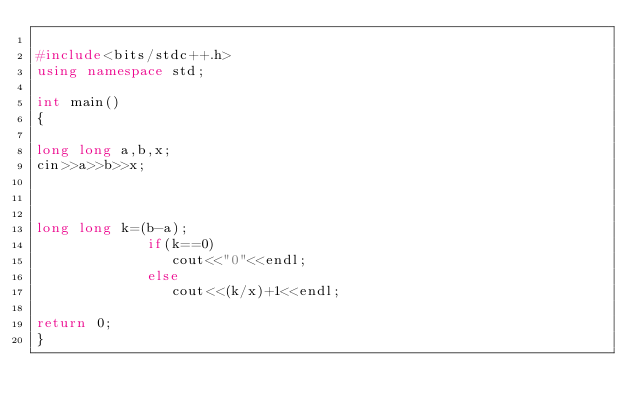<code> <loc_0><loc_0><loc_500><loc_500><_C++_>
#include<bits/stdc++.h>
using namespace std;

int main()
{

long long a,b,x;
cin>>a>>b>>x;



long long k=(b-a);
             if(k==0)
                cout<<"0"<<endl;
             else
                cout<<(k/x)+1<<endl;

return 0;
}

</code> 